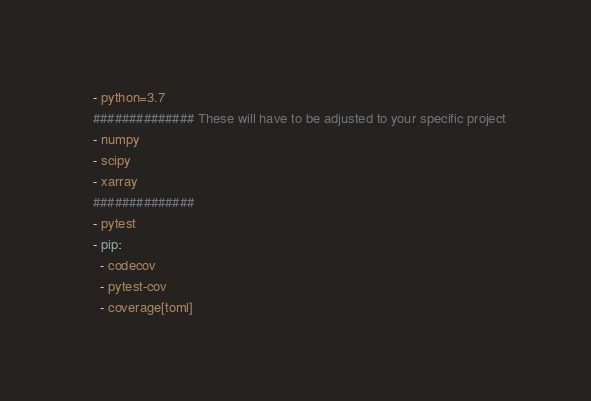<code> <loc_0><loc_0><loc_500><loc_500><_YAML_>  - python=3.7
  ############## These will have to be adjusted to your specific project
  - numpy
  - scipy
  - xarray
  ##############
  - pytest
  - pip:
    - codecov
    - pytest-cov
    - coverage[toml]</code> 